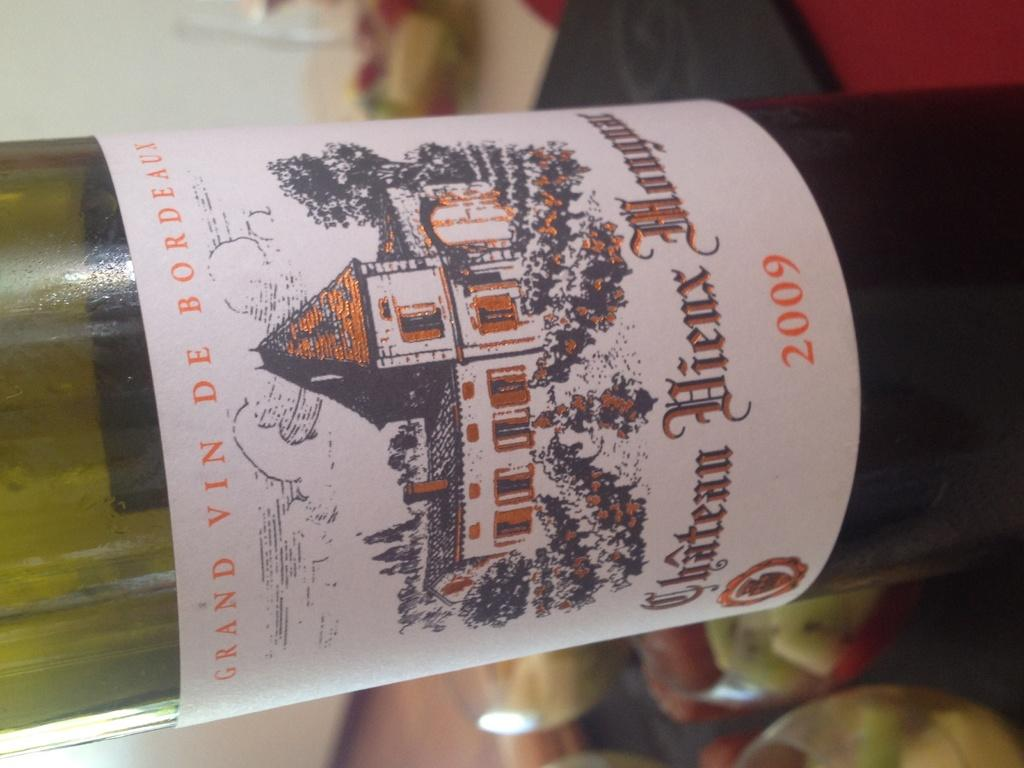What is the main object in the image? There is a wine bottle in the image. What color is the wine bottle? The wine bottle is green in color. Where is the wine bottle located? The wine bottle is on a table. Where is the toothbrush located in the image? There is no toothbrush present in the image. What is the grandmother doing in the image? There is no grandmother present in the image. 